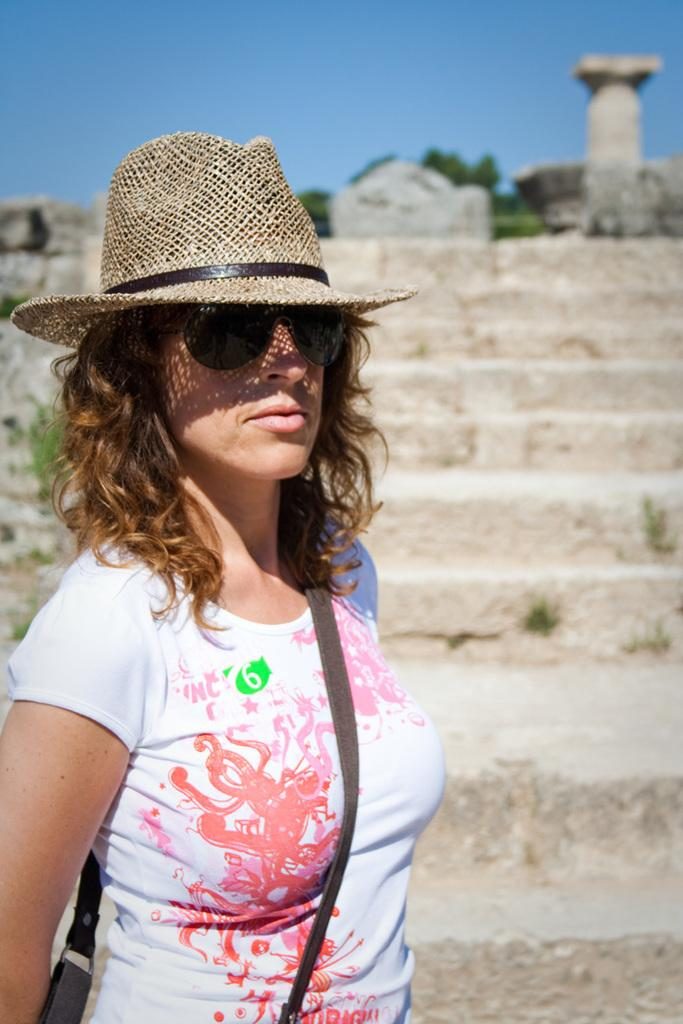Who is present in the image? There is a woman in the image. What is the woman wearing on her head? The woman is wearing a cap. What is the woman wearing to protect her eyes? The woman is wearing goggles. What can be seen in the background of the image? There are steps, stones, trees, and the sky visible in the background of the image. What verse is the woman reciting in the image? There is no indication in the image that the woman is reciting a verse, so it cannot be determined from the picture. 